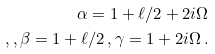<formula> <loc_0><loc_0><loc_500><loc_500>\alpha = 1 + \ell / 2 + 2 i \Omega \\ , , \beta = 1 + \ell / 2 \, , \gamma = 1 + 2 i \Omega \, .</formula> 